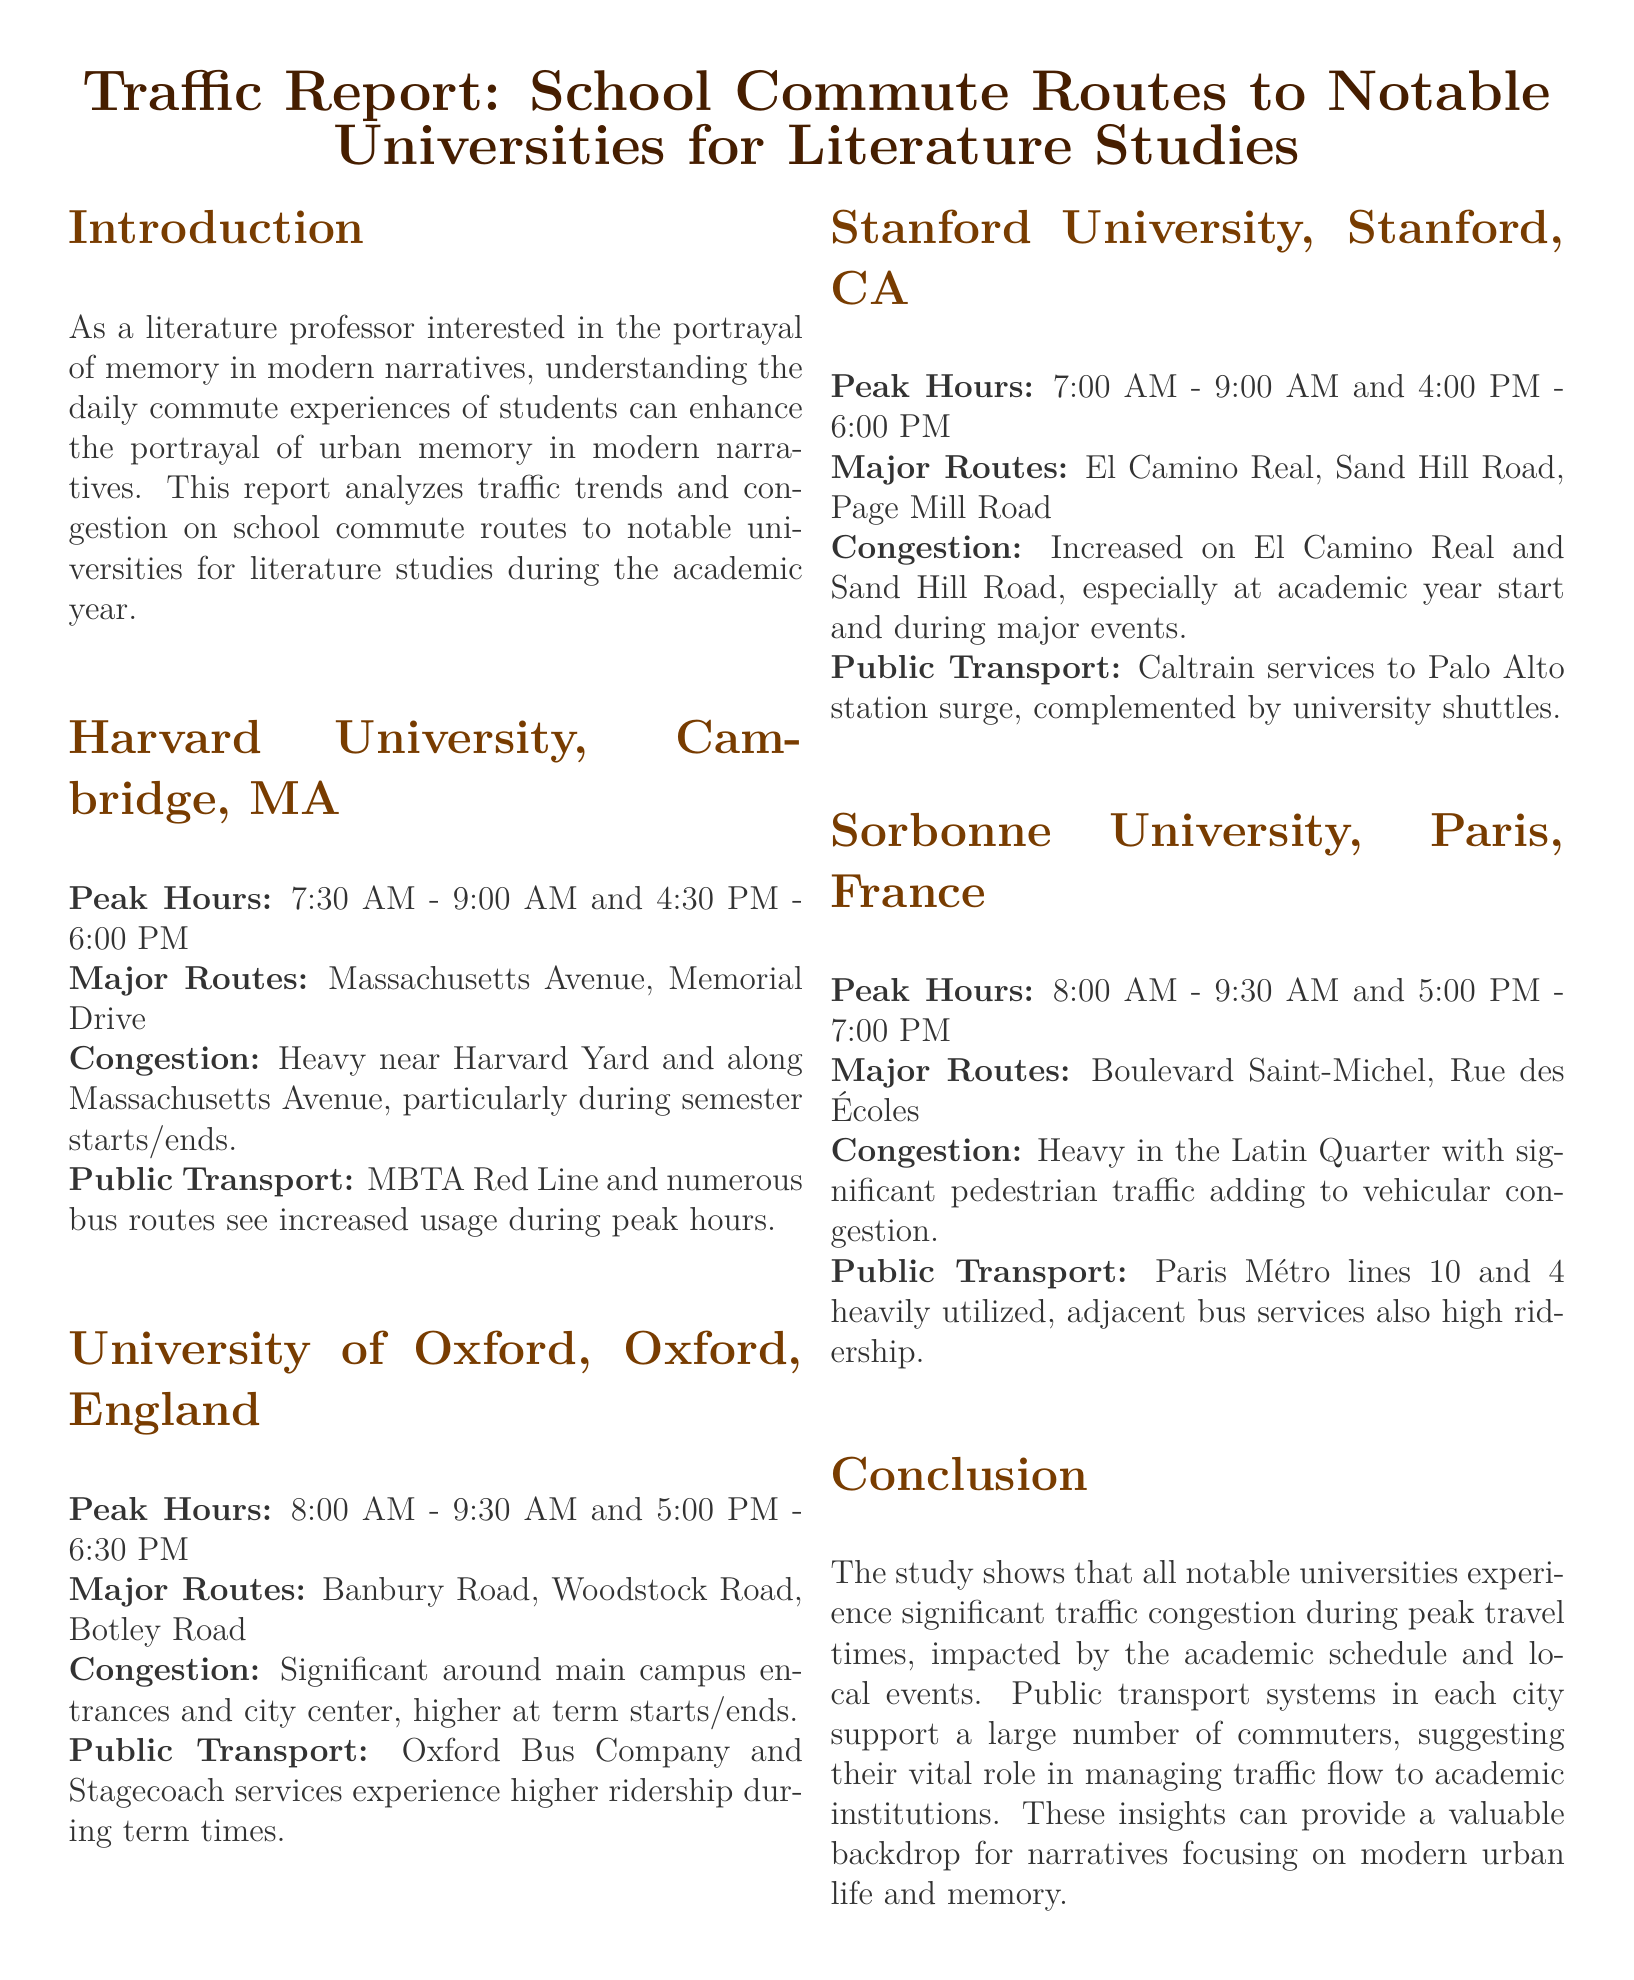what are the peak hours for Harvard University? The peak hours for Harvard University are mentioned in the document as 7:30 AM - 9:00 AM and 4:30 PM - 6:00 PM.
Answer: 7:30 AM - 9:00 AM and 4:30 PM - 6:00 PM which public transport services are mentioned for Stanford University? The document lists Caltrain services as well as university shuttles, indicating the public transport options available for Stanford University.
Answer: Caltrain services and university shuttles what is the major route for Sorbonne University? The document details Boulevard Saint-Michel and Rue des Écoles as major routes for Sorbonne University.
Answer: Boulevard Saint-Michel, Rue des Écoles how does public transport usage change during peak hours? The report indicates that public transport systems experience higher ridership during peak hours, especially during academic term times, impacting traffic congestion.
Answer: Higher ridership during peak hours which university has heavy congestion in the Latin Quarter? The report explicitly states that Sorbonne University experiences heavy congestion in the Latin Quarter.
Answer: Sorbonne University what is the primary congestion period for Oxford University? The document states that congestion around Oxford University is higher at term starts and ends, indicating specific congestion periods.
Answer: Term starts/ends what are the major routes for Harvard University? Massachusetts Avenue and Memorial Drive are identified as the major routes for Harvard University in the document.
Answer: Massachusetts Avenue, Memorial Drive what role do public transport systems play according to the report? The report suggests that public transport systems support a large number of commuters, playing a vital role in managing traffic flow to academic institutions.
Answer: Vital role in managing traffic flow what time is congestion noted to be heavy at Stanford University? The document notes increased congestion on El Camino Real and Sand Hill Road particularly at the academic year start and during major events.
Answer: Academic year start and major events 